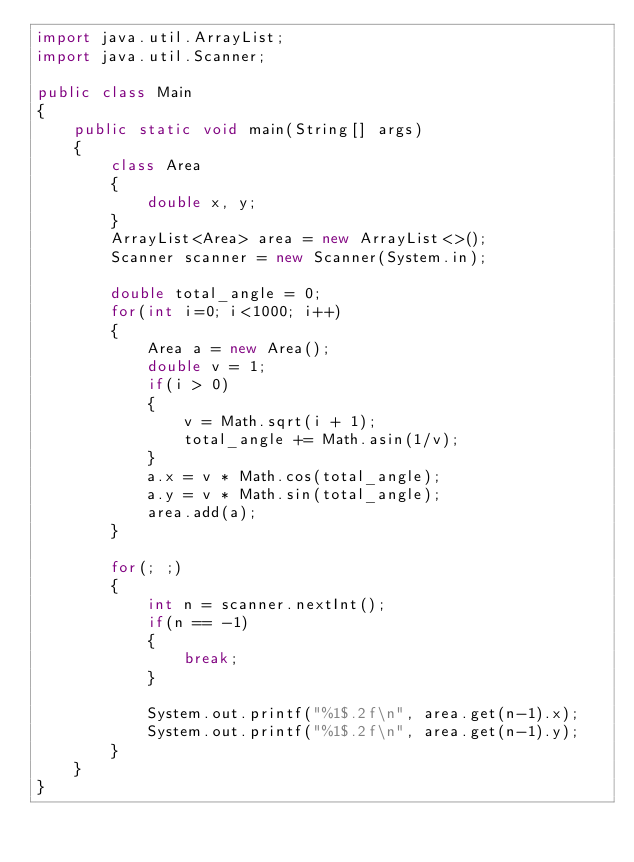<code> <loc_0><loc_0><loc_500><loc_500><_Java_>import java.util.ArrayList;
import java.util.Scanner;

public class Main 
{
	public static void main(String[] args)
	{
		class Area
		{
			double x, y;
		}
		ArrayList<Area> area = new ArrayList<>();
		Scanner scanner = new Scanner(System.in);
		
		double total_angle = 0;
		for(int i=0; i<1000; i++)
		{
			Area a = new Area();
			double v = 1;
			if(i > 0)
			{
				v = Math.sqrt(i + 1);
				total_angle += Math.asin(1/v);				
			}	
			a.x = v * Math.cos(total_angle);
			a.y = v * Math.sin(total_angle);		
			area.add(a);
		}
		
		for(; ;)
		{
			int n = scanner.nextInt();
			if(n == -1)
			{
				break;
			}
			
			System.out.printf("%1$.2f\n", area.get(n-1).x);
			System.out.printf("%1$.2f\n", area.get(n-1).y);
		}
	}
}</code> 